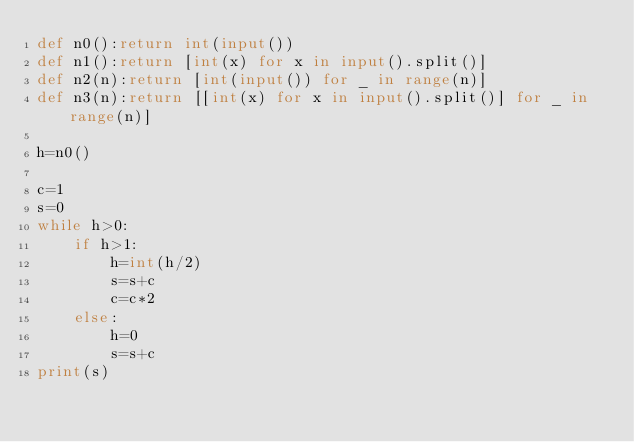Convert code to text. <code><loc_0><loc_0><loc_500><loc_500><_Python_>def n0():return int(input())
def n1():return [int(x) for x in input().split()]
def n2(n):return [int(input()) for _ in range(n)]
def n3(n):return [[int(x) for x in input().split()] for _ in range(n)]

h=n0()

c=1
s=0
while h>0:
    if h>1:
        h=int(h/2)
        s=s+c
        c=c*2
    else:
        h=0
        s=s+c
print(s)</code> 